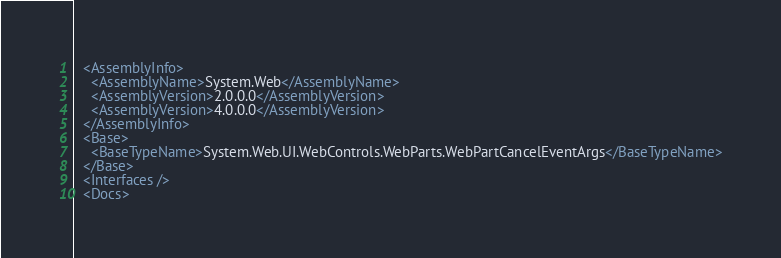<code> <loc_0><loc_0><loc_500><loc_500><_XML_>  <AssemblyInfo>
    <AssemblyName>System.Web</AssemblyName>
    <AssemblyVersion>2.0.0.0</AssemblyVersion>
    <AssemblyVersion>4.0.0.0</AssemblyVersion>
  </AssemblyInfo>
  <Base>
    <BaseTypeName>System.Web.UI.WebControls.WebParts.WebPartCancelEventArgs</BaseTypeName>
  </Base>
  <Interfaces />
  <Docs></code> 